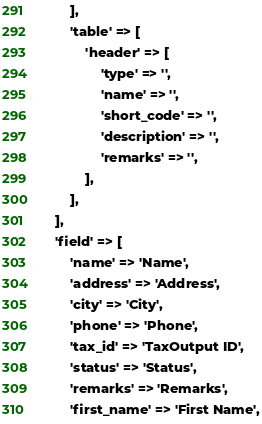Convert code to text. <code><loc_0><loc_0><loc_500><loc_500><_PHP_>        ],
        'table' => [
            'header' => [
                'type' => '',
                'name' => '',
                'short_code' => '',
                'description' => '',
                'remarks' => '',
            ],
        ],
    ],
    'field' => [
        'name' => 'Name',
        'address' => 'Address',
        'city' => 'City',
        'phone' => 'Phone',
        'tax_id' => 'TaxOutput ID',
        'status' => 'Status',
        'remarks' => 'Remarks',
        'first_name' => 'First Name',</code> 